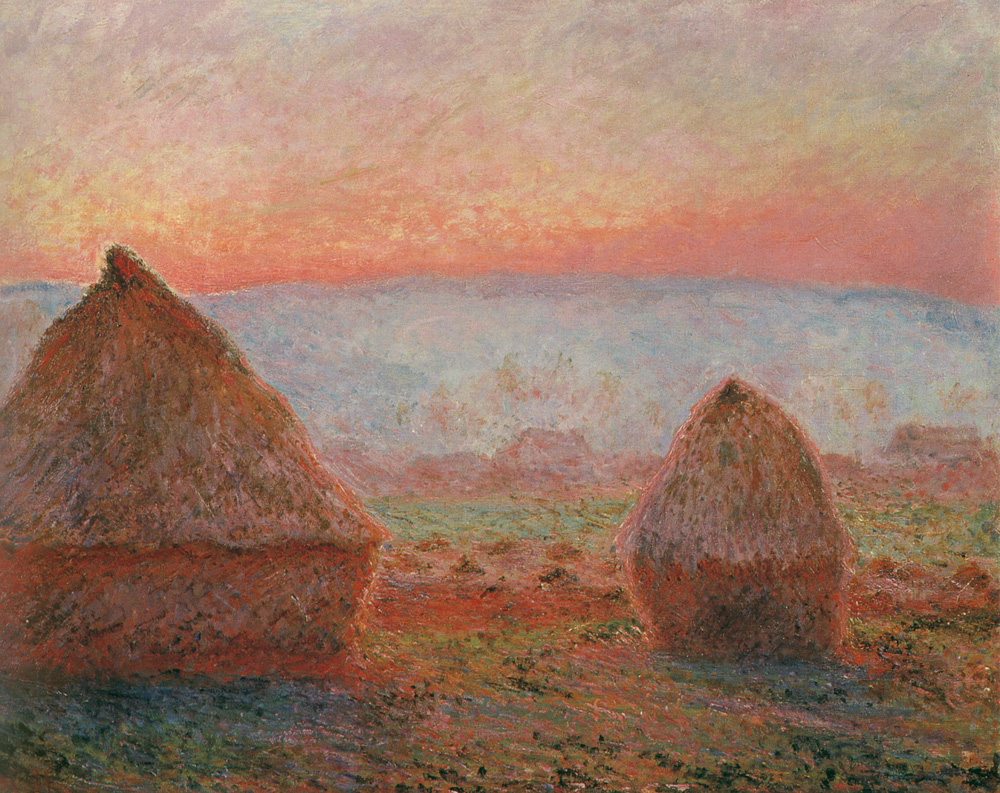How does the choice of colors affect the mood of this artwork? The artist's choice of warm shades of pink, orange, and red for the sky, contrasting with the earthy tones of the haystacks and ground, creates a deeply harmonious and soothing effect. These colors traditionally evoke feelings of warmth and calmness, suggesting that the scene is imbued with a quiet, contemplative mood typical of sunsets. This choice enhances the painting's ability to transport viewers to a tranquil, almost ethereal moment in time. 